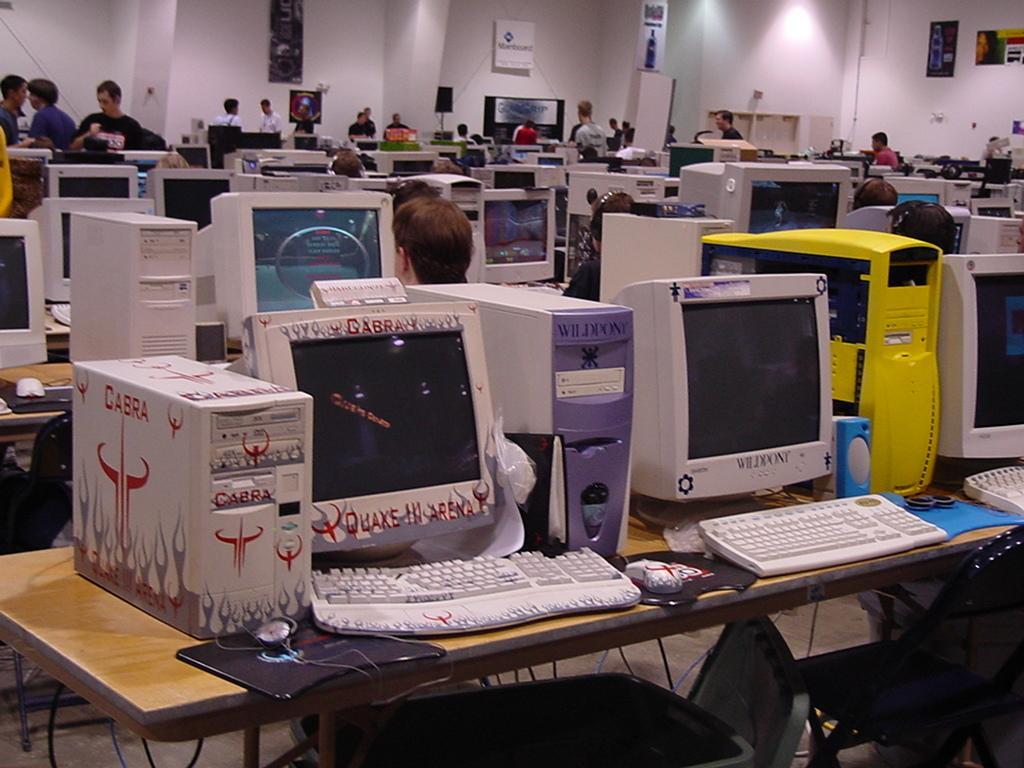Can you describe this image briefly? This is a picture taken in a center. In this room there is lot of monitors, cpu, keyboard, mouse on a table. There are the people who are working on a monitors and some people are standing and background of this people there is a white wall. 